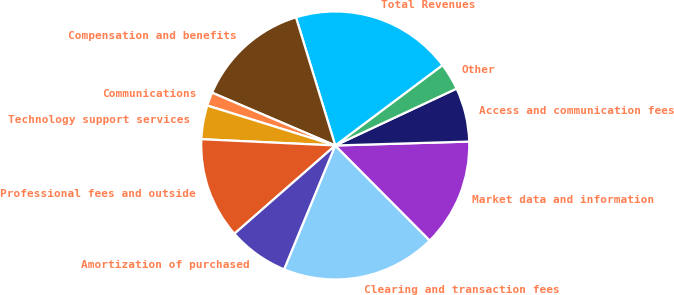Convert chart. <chart><loc_0><loc_0><loc_500><loc_500><pie_chart><fcel>Clearing and transaction fees<fcel>Market data and information<fcel>Access and communication fees<fcel>Other<fcel>Total Revenues<fcel>Compensation and benefits<fcel>Communications<fcel>Technology support services<fcel>Professional fees and outside<fcel>Amortization of purchased<nl><fcel>18.69%<fcel>13.01%<fcel>6.51%<fcel>3.26%<fcel>19.5%<fcel>13.82%<fcel>1.63%<fcel>4.07%<fcel>12.19%<fcel>7.32%<nl></chart> 